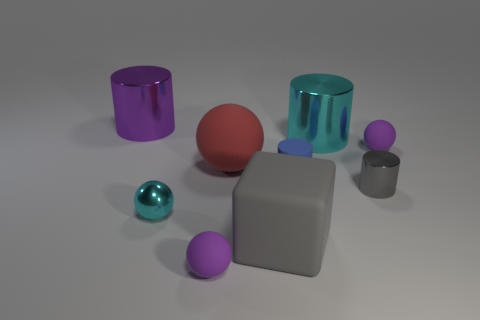Subtract all cubes. How many objects are left? 8 Add 4 large brown shiny objects. How many large brown shiny objects exist? 4 Subtract 1 gray blocks. How many objects are left? 8 Subtract all big blocks. Subtract all small cyan metallic things. How many objects are left? 7 Add 1 tiny purple spheres. How many tiny purple spheres are left? 3 